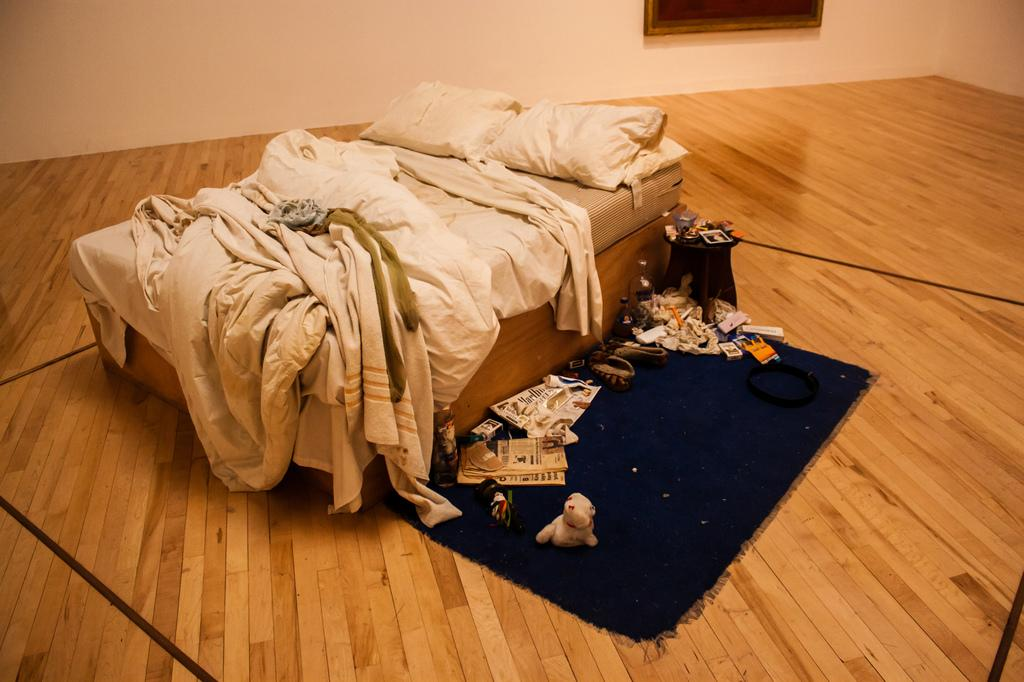What type of furniture is present in the image? There is a bed in the image. What is on the bed? The bed contains pillows and has bed sheets. What is in the middle of the image? There is a carpet in the middle of the image. What can be found on the carpet? The carpet contains some objects. What is visible at the top of the image? There is a wall at the top of the image. How many fingers can be seen on the head of the basketball in the image? There is no basketball present in the image, so it is not possible to determine the number of fingers on its head. 